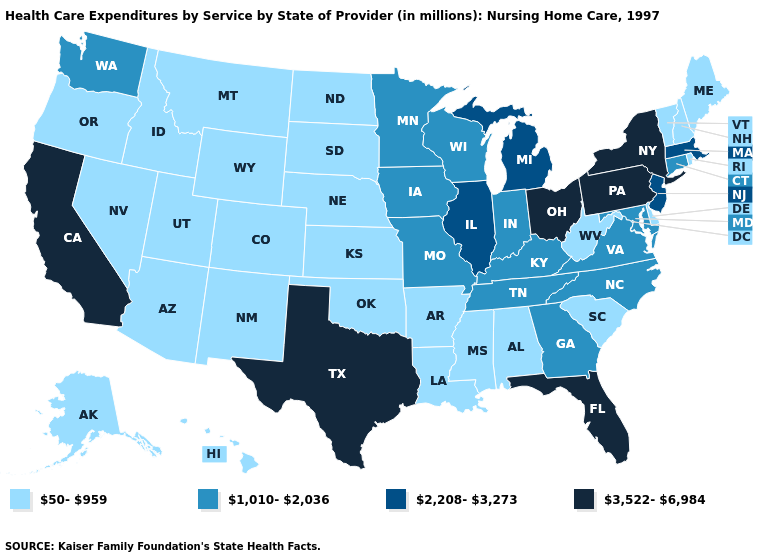Which states have the lowest value in the West?
Concise answer only. Alaska, Arizona, Colorado, Hawaii, Idaho, Montana, Nevada, New Mexico, Oregon, Utah, Wyoming. Among the states that border Michigan , does Indiana have the lowest value?
Be succinct. Yes. Does Florida have the highest value in the USA?
Answer briefly. Yes. What is the value of Florida?
Give a very brief answer. 3,522-6,984. What is the lowest value in the USA?
Concise answer only. 50-959. Does Massachusetts have a higher value than California?
Short answer required. No. Among the states that border Wisconsin , does Iowa have the highest value?
Write a very short answer. No. What is the value of Arizona?
Write a very short answer. 50-959. Does California have the highest value in the USA?
Quick response, please. Yes. What is the value of Iowa?
Keep it brief. 1,010-2,036. Is the legend a continuous bar?
Answer briefly. No. Name the states that have a value in the range 1,010-2,036?
Keep it brief. Connecticut, Georgia, Indiana, Iowa, Kentucky, Maryland, Minnesota, Missouri, North Carolina, Tennessee, Virginia, Washington, Wisconsin. Name the states that have a value in the range 3,522-6,984?
Give a very brief answer. California, Florida, New York, Ohio, Pennsylvania, Texas. What is the highest value in the USA?
Quick response, please. 3,522-6,984. What is the lowest value in states that border North Dakota?
Answer briefly. 50-959. 